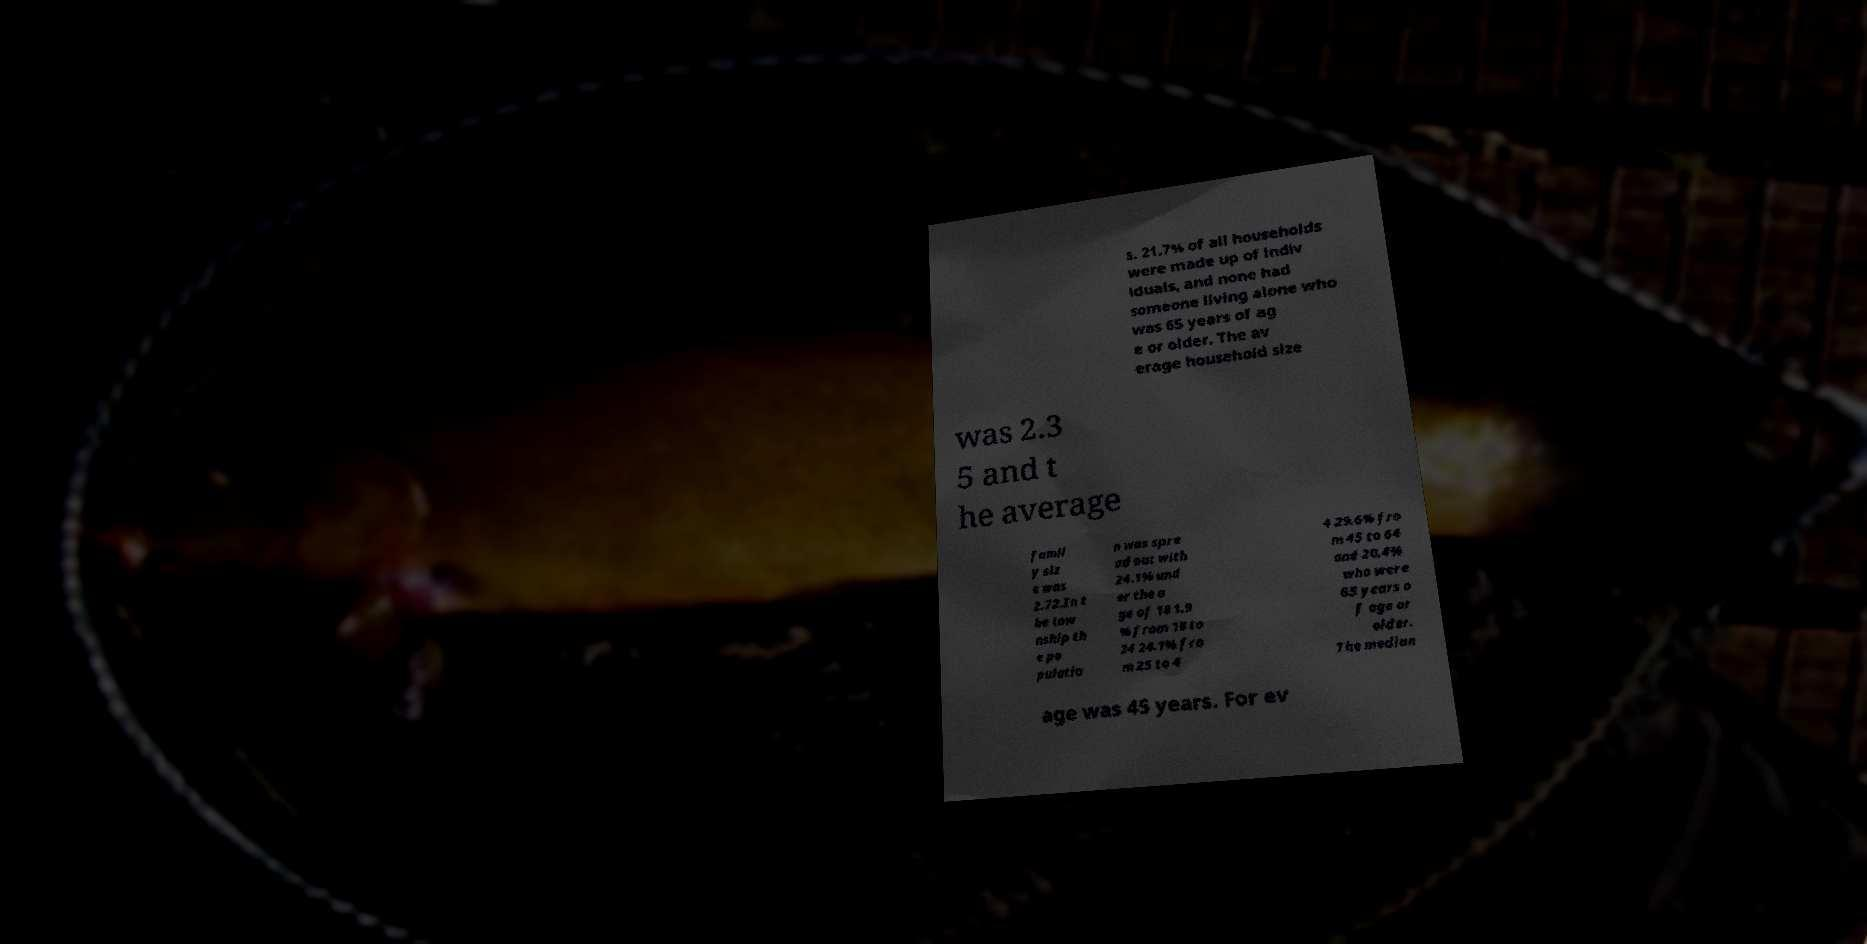Please identify and transcribe the text found in this image. s. 21.7% of all households were made up of indiv iduals, and none had someone living alone who was 65 years of ag e or older. The av erage household size was 2.3 5 and t he average famil y siz e was 2.72.In t he tow nship th e po pulatio n was spre ad out with 24.1% und er the a ge of 18 1.9 % from 18 to 24 24.1% fro m 25 to 4 4 29.6% fro m 45 to 64 and 20.4% who were 65 years o f age or older. The median age was 45 years. For ev 